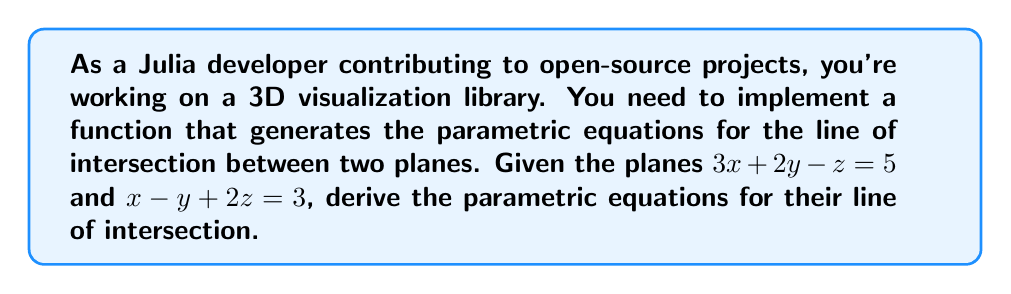Can you solve this math problem? Let's approach this step-by-step:

1) First, we need to find the direction vector of the line of intersection. This is given by the cross product of the normal vectors of the two planes.

   Plane 1: $3x + 2y - z = 5$ has normal vector $\mathbf{n_1} = (3, 2, -1)$
   Plane 2: $x - y + 2z = 3$ has normal vector $\mathbf{n_2} = (1, -1, 2)$

   Direction vector $\mathbf{d} = \mathbf{n_1} \times \mathbf{n_2}$:
   
   $$\mathbf{d} = \begin{vmatrix} 
   \mathbf{i} & \mathbf{j} & \mathbf{k} \\
   3 & 2 & -1 \\
   1 & -1 & 2
   \end{vmatrix} = (5)\mathbf{i} + (7)\mathbf{j} + (5)\mathbf{k}$$

2) Now we need to find a point on the line. We can do this by solving the system of equations:

   $$\begin{cases}
   3x + 2y - z = 5 \\
   x - y + 2z = 3 \\
   z = 0
   \end{cases}$$

   (We choose $z = 0$ for simplicity)

3) Solving this system:
   
   From the second equation with $z = 0$: $x - y = 3$
   Substituting into the first equation: $3x + 2(x-3) = 5$
   Simplifying: $5x - 6 = 5$, so $x = \frac{11}{5}$
   
   Then $y = x - 3 = \frac{11}{5} - 3 = -\frac{4}{5}$

   So, a point on the line is $P = (\frac{11}{5}, -\frac{4}{5}, 0)$

4) The parametric equations of the line are:

   $$\begin{cases}
   x = \frac{11}{5} + 5t \\
   y = -\frac{4}{5} + 7t \\
   z = 5t
   \end{cases}$$

   where $t$ is a parameter.

5) In Julia, you could implement this as:

   ```julia
   function line_intersection(t)
       x = 11/5 + 5t
       y = -4/5 + 7t
       z = 5t
       return [x, y, z]
   end
   ```
Answer: $x = \frac{11}{5} + 5t$, $y = -\frac{4}{5} + 7t$, $z = 5t$ 